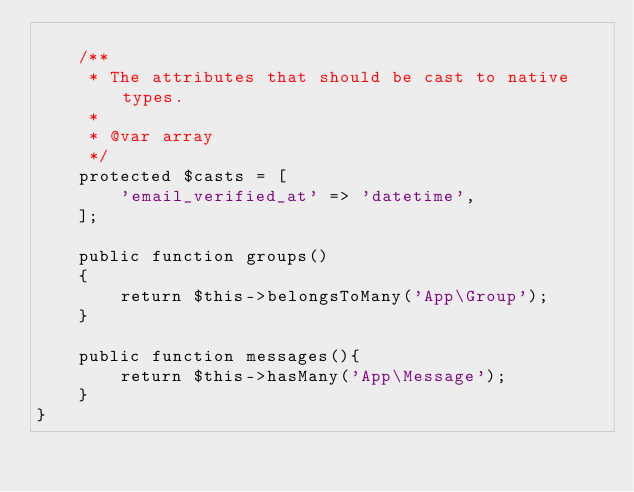Convert code to text. <code><loc_0><loc_0><loc_500><loc_500><_PHP_>
    /**
     * The attributes that should be cast to native types.
     *
     * @var array
     */
    protected $casts = [
        'email_verified_at' => 'datetime',
    ];

    public function groups()
    {
        return $this->belongsToMany('App\Group');
    }

    public function messages(){
        return $this->hasMany('App\Message');
    }
}
</code> 